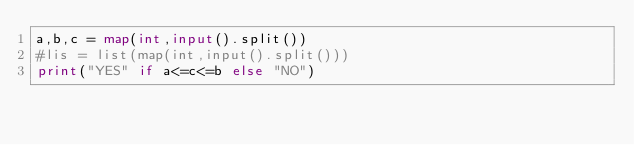Convert code to text. <code><loc_0><loc_0><loc_500><loc_500><_Python_>a,b,c = map(int,input().split())
#lis = list(map(int,input().split()))
print("YES" if a<=c<=b else "NO")</code> 